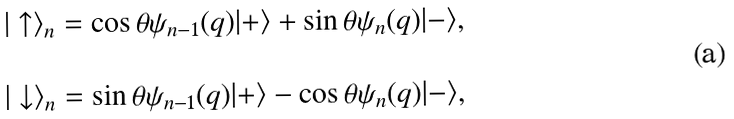Convert formula to latex. <formula><loc_0><loc_0><loc_500><loc_500>\begin{array} { l } | \uparrow \rangle _ { n } = \cos \theta \psi _ { n - 1 } ( q ) | + \rangle + \sin \theta \psi _ { n } ( q ) | - \rangle , \\ \\ | \downarrow \rangle _ { n } = \sin \theta \psi _ { n - 1 } ( q ) | + \rangle - \cos \theta \psi _ { n } ( q ) | - \rangle , \end{array}</formula> 